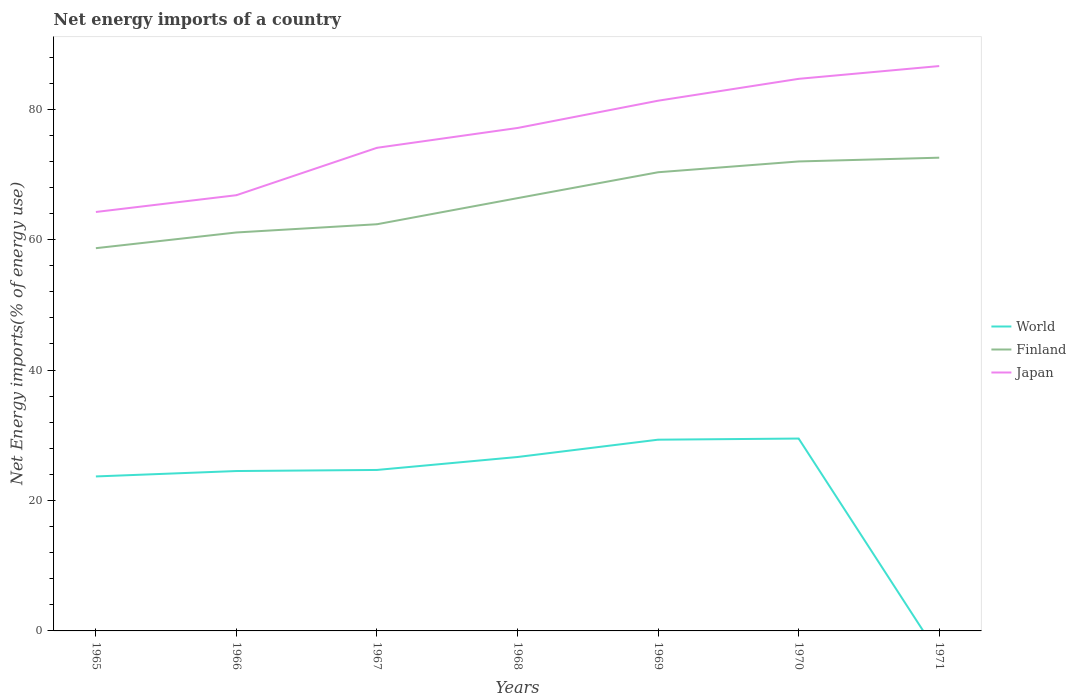How many different coloured lines are there?
Your answer should be very brief. 3. Does the line corresponding to World intersect with the line corresponding to Japan?
Keep it short and to the point. No. Across all years, what is the maximum net energy imports in Finland?
Provide a short and direct response. 58.69. What is the total net energy imports in World in the graph?
Offer a terse response. -4.81. What is the difference between the highest and the second highest net energy imports in Finland?
Your answer should be compact. 13.88. How many lines are there?
Give a very brief answer. 3. How many years are there in the graph?
Provide a short and direct response. 7. Are the values on the major ticks of Y-axis written in scientific E-notation?
Offer a terse response. No. Does the graph contain any zero values?
Make the answer very short. Yes. Where does the legend appear in the graph?
Provide a succinct answer. Center right. How are the legend labels stacked?
Your response must be concise. Vertical. What is the title of the graph?
Offer a very short reply. Net energy imports of a country. Does "Malawi" appear as one of the legend labels in the graph?
Provide a succinct answer. No. What is the label or title of the X-axis?
Offer a terse response. Years. What is the label or title of the Y-axis?
Offer a terse response. Net Energy imports(% of energy use). What is the Net Energy imports(% of energy use) in World in 1965?
Give a very brief answer. 23.69. What is the Net Energy imports(% of energy use) in Finland in 1965?
Provide a short and direct response. 58.69. What is the Net Energy imports(% of energy use) in Japan in 1965?
Offer a terse response. 64.25. What is the Net Energy imports(% of energy use) of World in 1966?
Make the answer very short. 24.52. What is the Net Energy imports(% of energy use) in Finland in 1966?
Provide a succinct answer. 61.1. What is the Net Energy imports(% of energy use) in Japan in 1966?
Your answer should be compact. 66.82. What is the Net Energy imports(% of energy use) of World in 1967?
Your answer should be compact. 24.69. What is the Net Energy imports(% of energy use) in Finland in 1967?
Ensure brevity in your answer.  62.36. What is the Net Energy imports(% of energy use) of Japan in 1967?
Your answer should be compact. 74.09. What is the Net Energy imports(% of energy use) in World in 1968?
Provide a succinct answer. 26.67. What is the Net Energy imports(% of energy use) in Finland in 1968?
Provide a short and direct response. 66.37. What is the Net Energy imports(% of energy use) in Japan in 1968?
Make the answer very short. 77.13. What is the Net Energy imports(% of energy use) of World in 1969?
Provide a succinct answer. 29.33. What is the Net Energy imports(% of energy use) in Finland in 1969?
Your response must be concise. 70.34. What is the Net Energy imports(% of energy use) in Japan in 1969?
Your response must be concise. 81.31. What is the Net Energy imports(% of energy use) of World in 1970?
Provide a short and direct response. 29.5. What is the Net Energy imports(% of energy use) of Finland in 1970?
Your answer should be very brief. 71.99. What is the Net Energy imports(% of energy use) in Japan in 1970?
Make the answer very short. 84.66. What is the Net Energy imports(% of energy use) in Finland in 1971?
Offer a terse response. 72.57. What is the Net Energy imports(% of energy use) of Japan in 1971?
Your answer should be compact. 86.62. Across all years, what is the maximum Net Energy imports(% of energy use) in World?
Your answer should be very brief. 29.5. Across all years, what is the maximum Net Energy imports(% of energy use) in Finland?
Make the answer very short. 72.57. Across all years, what is the maximum Net Energy imports(% of energy use) of Japan?
Keep it short and to the point. 86.62. Across all years, what is the minimum Net Energy imports(% of energy use) of World?
Offer a terse response. 0. Across all years, what is the minimum Net Energy imports(% of energy use) in Finland?
Offer a terse response. 58.69. Across all years, what is the minimum Net Energy imports(% of energy use) in Japan?
Your response must be concise. 64.25. What is the total Net Energy imports(% of energy use) in World in the graph?
Keep it short and to the point. 158.39. What is the total Net Energy imports(% of energy use) in Finland in the graph?
Give a very brief answer. 463.43. What is the total Net Energy imports(% of energy use) in Japan in the graph?
Offer a very short reply. 534.88. What is the difference between the Net Energy imports(% of energy use) in World in 1965 and that in 1966?
Make the answer very short. -0.83. What is the difference between the Net Energy imports(% of energy use) in Finland in 1965 and that in 1966?
Your answer should be very brief. -2.41. What is the difference between the Net Energy imports(% of energy use) in Japan in 1965 and that in 1966?
Offer a terse response. -2.57. What is the difference between the Net Energy imports(% of energy use) of World in 1965 and that in 1967?
Provide a succinct answer. -0.99. What is the difference between the Net Energy imports(% of energy use) of Finland in 1965 and that in 1967?
Your answer should be compact. -3.67. What is the difference between the Net Energy imports(% of energy use) in Japan in 1965 and that in 1967?
Offer a very short reply. -9.84. What is the difference between the Net Energy imports(% of energy use) in World in 1965 and that in 1968?
Your response must be concise. -2.98. What is the difference between the Net Energy imports(% of energy use) in Finland in 1965 and that in 1968?
Provide a succinct answer. -7.67. What is the difference between the Net Energy imports(% of energy use) in Japan in 1965 and that in 1968?
Keep it short and to the point. -12.88. What is the difference between the Net Energy imports(% of energy use) of World in 1965 and that in 1969?
Provide a succinct answer. -5.64. What is the difference between the Net Energy imports(% of energy use) of Finland in 1965 and that in 1969?
Offer a very short reply. -11.65. What is the difference between the Net Energy imports(% of energy use) of Japan in 1965 and that in 1969?
Your answer should be compact. -17.06. What is the difference between the Net Energy imports(% of energy use) of World in 1965 and that in 1970?
Your response must be concise. -5.81. What is the difference between the Net Energy imports(% of energy use) of Finland in 1965 and that in 1970?
Keep it short and to the point. -13.3. What is the difference between the Net Energy imports(% of energy use) in Japan in 1965 and that in 1970?
Make the answer very short. -20.42. What is the difference between the Net Energy imports(% of energy use) of Finland in 1965 and that in 1971?
Provide a succinct answer. -13.88. What is the difference between the Net Energy imports(% of energy use) of Japan in 1965 and that in 1971?
Your answer should be compact. -22.38. What is the difference between the Net Energy imports(% of energy use) of World in 1966 and that in 1967?
Provide a short and direct response. -0.17. What is the difference between the Net Energy imports(% of energy use) of Finland in 1966 and that in 1967?
Your answer should be compact. -1.26. What is the difference between the Net Energy imports(% of energy use) of Japan in 1966 and that in 1967?
Offer a very short reply. -7.27. What is the difference between the Net Energy imports(% of energy use) in World in 1966 and that in 1968?
Keep it short and to the point. -2.15. What is the difference between the Net Energy imports(% of energy use) in Finland in 1966 and that in 1968?
Your answer should be compact. -5.26. What is the difference between the Net Energy imports(% of energy use) in Japan in 1966 and that in 1968?
Provide a succinct answer. -10.31. What is the difference between the Net Energy imports(% of energy use) in World in 1966 and that in 1969?
Provide a succinct answer. -4.81. What is the difference between the Net Energy imports(% of energy use) of Finland in 1966 and that in 1969?
Give a very brief answer. -9.23. What is the difference between the Net Energy imports(% of energy use) in Japan in 1966 and that in 1969?
Your answer should be very brief. -14.49. What is the difference between the Net Energy imports(% of energy use) in World in 1966 and that in 1970?
Provide a succinct answer. -4.98. What is the difference between the Net Energy imports(% of energy use) in Finland in 1966 and that in 1970?
Offer a very short reply. -10.89. What is the difference between the Net Energy imports(% of energy use) of Japan in 1966 and that in 1970?
Give a very brief answer. -17.84. What is the difference between the Net Energy imports(% of energy use) of Finland in 1966 and that in 1971?
Offer a very short reply. -11.47. What is the difference between the Net Energy imports(% of energy use) in Japan in 1966 and that in 1971?
Offer a very short reply. -19.8. What is the difference between the Net Energy imports(% of energy use) in World in 1967 and that in 1968?
Give a very brief answer. -1.99. What is the difference between the Net Energy imports(% of energy use) in Finland in 1967 and that in 1968?
Your response must be concise. -4. What is the difference between the Net Energy imports(% of energy use) of Japan in 1967 and that in 1968?
Give a very brief answer. -3.04. What is the difference between the Net Energy imports(% of energy use) in World in 1967 and that in 1969?
Offer a very short reply. -4.64. What is the difference between the Net Energy imports(% of energy use) in Finland in 1967 and that in 1969?
Give a very brief answer. -7.97. What is the difference between the Net Energy imports(% of energy use) in Japan in 1967 and that in 1969?
Your response must be concise. -7.22. What is the difference between the Net Energy imports(% of energy use) of World in 1967 and that in 1970?
Provide a short and direct response. -4.81. What is the difference between the Net Energy imports(% of energy use) of Finland in 1967 and that in 1970?
Make the answer very short. -9.63. What is the difference between the Net Energy imports(% of energy use) of Japan in 1967 and that in 1970?
Your answer should be compact. -10.58. What is the difference between the Net Energy imports(% of energy use) in Finland in 1967 and that in 1971?
Offer a terse response. -10.21. What is the difference between the Net Energy imports(% of energy use) in Japan in 1967 and that in 1971?
Your answer should be very brief. -12.54. What is the difference between the Net Energy imports(% of energy use) in World in 1968 and that in 1969?
Provide a succinct answer. -2.66. What is the difference between the Net Energy imports(% of energy use) of Finland in 1968 and that in 1969?
Your answer should be very brief. -3.97. What is the difference between the Net Energy imports(% of energy use) of Japan in 1968 and that in 1969?
Ensure brevity in your answer.  -4.18. What is the difference between the Net Energy imports(% of energy use) in World in 1968 and that in 1970?
Your response must be concise. -2.83. What is the difference between the Net Energy imports(% of energy use) of Finland in 1968 and that in 1970?
Provide a short and direct response. -5.63. What is the difference between the Net Energy imports(% of energy use) in Japan in 1968 and that in 1970?
Your answer should be very brief. -7.54. What is the difference between the Net Energy imports(% of energy use) of Finland in 1968 and that in 1971?
Provide a succinct answer. -6.2. What is the difference between the Net Energy imports(% of energy use) in Japan in 1968 and that in 1971?
Ensure brevity in your answer.  -9.5. What is the difference between the Net Energy imports(% of energy use) of World in 1969 and that in 1970?
Your response must be concise. -0.17. What is the difference between the Net Energy imports(% of energy use) of Finland in 1969 and that in 1970?
Your answer should be compact. -1.65. What is the difference between the Net Energy imports(% of energy use) in Japan in 1969 and that in 1970?
Make the answer very short. -3.35. What is the difference between the Net Energy imports(% of energy use) in Finland in 1969 and that in 1971?
Keep it short and to the point. -2.23. What is the difference between the Net Energy imports(% of energy use) in Japan in 1969 and that in 1971?
Offer a very short reply. -5.31. What is the difference between the Net Energy imports(% of energy use) of Finland in 1970 and that in 1971?
Make the answer very short. -0.58. What is the difference between the Net Energy imports(% of energy use) in Japan in 1970 and that in 1971?
Your answer should be compact. -1.96. What is the difference between the Net Energy imports(% of energy use) of World in 1965 and the Net Energy imports(% of energy use) of Finland in 1966?
Keep it short and to the point. -37.41. What is the difference between the Net Energy imports(% of energy use) in World in 1965 and the Net Energy imports(% of energy use) in Japan in 1966?
Provide a short and direct response. -43.13. What is the difference between the Net Energy imports(% of energy use) in Finland in 1965 and the Net Energy imports(% of energy use) in Japan in 1966?
Your answer should be very brief. -8.13. What is the difference between the Net Energy imports(% of energy use) in World in 1965 and the Net Energy imports(% of energy use) in Finland in 1967?
Ensure brevity in your answer.  -38.67. What is the difference between the Net Energy imports(% of energy use) of World in 1965 and the Net Energy imports(% of energy use) of Japan in 1967?
Your answer should be very brief. -50.4. What is the difference between the Net Energy imports(% of energy use) in Finland in 1965 and the Net Energy imports(% of energy use) in Japan in 1967?
Make the answer very short. -15.39. What is the difference between the Net Energy imports(% of energy use) in World in 1965 and the Net Energy imports(% of energy use) in Finland in 1968?
Keep it short and to the point. -42.68. What is the difference between the Net Energy imports(% of energy use) of World in 1965 and the Net Energy imports(% of energy use) of Japan in 1968?
Your response must be concise. -53.44. What is the difference between the Net Energy imports(% of energy use) in Finland in 1965 and the Net Energy imports(% of energy use) in Japan in 1968?
Your answer should be very brief. -18.43. What is the difference between the Net Energy imports(% of energy use) in World in 1965 and the Net Energy imports(% of energy use) in Finland in 1969?
Your answer should be very brief. -46.65. What is the difference between the Net Energy imports(% of energy use) of World in 1965 and the Net Energy imports(% of energy use) of Japan in 1969?
Make the answer very short. -57.62. What is the difference between the Net Energy imports(% of energy use) in Finland in 1965 and the Net Energy imports(% of energy use) in Japan in 1969?
Make the answer very short. -22.62. What is the difference between the Net Energy imports(% of energy use) of World in 1965 and the Net Energy imports(% of energy use) of Finland in 1970?
Provide a succinct answer. -48.3. What is the difference between the Net Energy imports(% of energy use) of World in 1965 and the Net Energy imports(% of energy use) of Japan in 1970?
Offer a very short reply. -60.97. What is the difference between the Net Energy imports(% of energy use) of Finland in 1965 and the Net Energy imports(% of energy use) of Japan in 1970?
Ensure brevity in your answer.  -25.97. What is the difference between the Net Energy imports(% of energy use) of World in 1965 and the Net Energy imports(% of energy use) of Finland in 1971?
Provide a succinct answer. -48.88. What is the difference between the Net Energy imports(% of energy use) in World in 1965 and the Net Energy imports(% of energy use) in Japan in 1971?
Provide a succinct answer. -62.93. What is the difference between the Net Energy imports(% of energy use) of Finland in 1965 and the Net Energy imports(% of energy use) of Japan in 1971?
Offer a terse response. -27.93. What is the difference between the Net Energy imports(% of energy use) in World in 1966 and the Net Energy imports(% of energy use) in Finland in 1967?
Offer a terse response. -37.85. What is the difference between the Net Energy imports(% of energy use) in World in 1966 and the Net Energy imports(% of energy use) in Japan in 1967?
Provide a short and direct response. -49.57. What is the difference between the Net Energy imports(% of energy use) of Finland in 1966 and the Net Energy imports(% of energy use) of Japan in 1967?
Make the answer very short. -12.98. What is the difference between the Net Energy imports(% of energy use) in World in 1966 and the Net Energy imports(% of energy use) in Finland in 1968?
Give a very brief answer. -41.85. What is the difference between the Net Energy imports(% of energy use) of World in 1966 and the Net Energy imports(% of energy use) of Japan in 1968?
Provide a succinct answer. -52.61. What is the difference between the Net Energy imports(% of energy use) of Finland in 1966 and the Net Energy imports(% of energy use) of Japan in 1968?
Ensure brevity in your answer.  -16.02. What is the difference between the Net Energy imports(% of energy use) in World in 1966 and the Net Energy imports(% of energy use) in Finland in 1969?
Your answer should be compact. -45.82. What is the difference between the Net Energy imports(% of energy use) in World in 1966 and the Net Energy imports(% of energy use) in Japan in 1969?
Your response must be concise. -56.79. What is the difference between the Net Energy imports(% of energy use) of Finland in 1966 and the Net Energy imports(% of energy use) of Japan in 1969?
Give a very brief answer. -20.21. What is the difference between the Net Energy imports(% of energy use) in World in 1966 and the Net Energy imports(% of energy use) in Finland in 1970?
Offer a terse response. -47.47. What is the difference between the Net Energy imports(% of energy use) in World in 1966 and the Net Energy imports(% of energy use) in Japan in 1970?
Provide a short and direct response. -60.14. What is the difference between the Net Energy imports(% of energy use) of Finland in 1966 and the Net Energy imports(% of energy use) of Japan in 1970?
Make the answer very short. -23.56. What is the difference between the Net Energy imports(% of energy use) of World in 1966 and the Net Energy imports(% of energy use) of Finland in 1971?
Offer a terse response. -48.05. What is the difference between the Net Energy imports(% of energy use) of World in 1966 and the Net Energy imports(% of energy use) of Japan in 1971?
Offer a very short reply. -62.1. What is the difference between the Net Energy imports(% of energy use) in Finland in 1966 and the Net Energy imports(% of energy use) in Japan in 1971?
Make the answer very short. -25.52. What is the difference between the Net Energy imports(% of energy use) of World in 1967 and the Net Energy imports(% of energy use) of Finland in 1968?
Offer a terse response. -41.68. What is the difference between the Net Energy imports(% of energy use) of World in 1967 and the Net Energy imports(% of energy use) of Japan in 1968?
Keep it short and to the point. -52.44. What is the difference between the Net Energy imports(% of energy use) in Finland in 1967 and the Net Energy imports(% of energy use) in Japan in 1968?
Make the answer very short. -14.76. What is the difference between the Net Energy imports(% of energy use) of World in 1967 and the Net Energy imports(% of energy use) of Finland in 1969?
Your answer should be very brief. -45.65. What is the difference between the Net Energy imports(% of energy use) of World in 1967 and the Net Energy imports(% of energy use) of Japan in 1969?
Give a very brief answer. -56.62. What is the difference between the Net Energy imports(% of energy use) in Finland in 1967 and the Net Energy imports(% of energy use) in Japan in 1969?
Offer a terse response. -18.94. What is the difference between the Net Energy imports(% of energy use) in World in 1967 and the Net Energy imports(% of energy use) in Finland in 1970?
Your answer should be compact. -47.31. What is the difference between the Net Energy imports(% of energy use) in World in 1967 and the Net Energy imports(% of energy use) in Japan in 1970?
Your response must be concise. -59.98. What is the difference between the Net Energy imports(% of energy use) in Finland in 1967 and the Net Energy imports(% of energy use) in Japan in 1970?
Keep it short and to the point. -22.3. What is the difference between the Net Energy imports(% of energy use) of World in 1967 and the Net Energy imports(% of energy use) of Finland in 1971?
Offer a terse response. -47.89. What is the difference between the Net Energy imports(% of energy use) in World in 1967 and the Net Energy imports(% of energy use) in Japan in 1971?
Keep it short and to the point. -61.94. What is the difference between the Net Energy imports(% of energy use) of Finland in 1967 and the Net Energy imports(% of energy use) of Japan in 1971?
Ensure brevity in your answer.  -24.26. What is the difference between the Net Energy imports(% of energy use) in World in 1968 and the Net Energy imports(% of energy use) in Finland in 1969?
Your answer should be compact. -43.67. What is the difference between the Net Energy imports(% of energy use) of World in 1968 and the Net Energy imports(% of energy use) of Japan in 1969?
Offer a very short reply. -54.64. What is the difference between the Net Energy imports(% of energy use) in Finland in 1968 and the Net Energy imports(% of energy use) in Japan in 1969?
Keep it short and to the point. -14.94. What is the difference between the Net Energy imports(% of energy use) of World in 1968 and the Net Energy imports(% of energy use) of Finland in 1970?
Your response must be concise. -45.32. What is the difference between the Net Energy imports(% of energy use) of World in 1968 and the Net Energy imports(% of energy use) of Japan in 1970?
Your answer should be very brief. -57.99. What is the difference between the Net Energy imports(% of energy use) of Finland in 1968 and the Net Energy imports(% of energy use) of Japan in 1970?
Your response must be concise. -18.3. What is the difference between the Net Energy imports(% of energy use) in World in 1968 and the Net Energy imports(% of energy use) in Finland in 1971?
Give a very brief answer. -45.9. What is the difference between the Net Energy imports(% of energy use) in World in 1968 and the Net Energy imports(% of energy use) in Japan in 1971?
Your response must be concise. -59.95. What is the difference between the Net Energy imports(% of energy use) of Finland in 1968 and the Net Energy imports(% of energy use) of Japan in 1971?
Provide a succinct answer. -20.26. What is the difference between the Net Energy imports(% of energy use) of World in 1969 and the Net Energy imports(% of energy use) of Finland in 1970?
Your answer should be very brief. -42.67. What is the difference between the Net Energy imports(% of energy use) of World in 1969 and the Net Energy imports(% of energy use) of Japan in 1970?
Provide a succinct answer. -55.34. What is the difference between the Net Energy imports(% of energy use) of Finland in 1969 and the Net Energy imports(% of energy use) of Japan in 1970?
Provide a short and direct response. -14.32. What is the difference between the Net Energy imports(% of energy use) in World in 1969 and the Net Energy imports(% of energy use) in Finland in 1971?
Keep it short and to the point. -43.25. What is the difference between the Net Energy imports(% of energy use) in World in 1969 and the Net Energy imports(% of energy use) in Japan in 1971?
Provide a succinct answer. -57.3. What is the difference between the Net Energy imports(% of energy use) in Finland in 1969 and the Net Energy imports(% of energy use) in Japan in 1971?
Your answer should be compact. -16.28. What is the difference between the Net Energy imports(% of energy use) in World in 1970 and the Net Energy imports(% of energy use) in Finland in 1971?
Give a very brief answer. -43.07. What is the difference between the Net Energy imports(% of energy use) of World in 1970 and the Net Energy imports(% of energy use) of Japan in 1971?
Your answer should be compact. -57.12. What is the difference between the Net Energy imports(% of energy use) in Finland in 1970 and the Net Energy imports(% of energy use) in Japan in 1971?
Make the answer very short. -14.63. What is the average Net Energy imports(% of energy use) of World per year?
Your response must be concise. 22.63. What is the average Net Energy imports(% of energy use) in Finland per year?
Keep it short and to the point. 66.2. What is the average Net Energy imports(% of energy use) of Japan per year?
Ensure brevity in your answer.  76.41. In the year 1965, what is the difference between the Net Energy imports(% of energy use) of World and Net Energy imports(% of energy use) of Finland?
Make the answer very short. -35. In the year 1965, what is the difference between the Net Energy imports(% of energy use) of World and Net Energy imports(% of energy use) of Japan?
Provide a succinct answer. -40.55. In the year 1965, what is the difference between the Net Energy imports(% of energy use) of Finland and Net Energy imports(% of energy use) of Japan?
Keep it short and to the point. -5.55. In the year 1966, what is the difference between the Net Energy imports(% of energy use) of World and Net Energy imports(% of energy use) of Finland?
Provide a short and direct response. -36.58. In the year 1966, what is the difference between the Net Energy imports(% of energy use) in World and Net Energy imports(% of energy use) in Japan?
Offer a very short reply. -42.3. In the year 1966, what is the difference between the Net Energy imports(% of energy use) of Finland and Net Energy imports(% of energy use) of Japan?
Your response must be concise. -5.71. In the year 1967, what is the difference between the Net Energy imports(% of energy use) of World and Net Energy imports(% of energy use) of Finland?
Keep it short and to the point. -37.68. In the year 1967, what is the difference between the Net Energy imports(% of energy use) of World and Net Energy imports(% of energy use) of Japan?
Your answer should be compact. -49.4. In the year 1967, what is the difference between the Net Energy imports(% of energy use) in Finland and Net Energy imports(% of energy use) in Japan?
Ensure brevity in your answer.  -11.72. In the year 1968, what is the difference between the Net Energy imports(% of energy use) of World and Net Energy imports(% of energy use) of Finland?
Your response must be concise. -39.7. In the year 1968, what is the difference between the Net Energy imports(% of energy use) of World and Net Energy imports(% of energy use) of Japan?
Offer a very short reply. -50.46. In the year 1968, what is the difference between the Net Energy imports(% of energy use) in Finland and Net Energy imports(% of energy use) in Japan?
Keep it short and to the point. -10.76. In the year 1969, what is the difference between the Net Energy imports(% of energy use) of World and Net Energy imports(% of energy use) of Finland?
Your answer should be very brief. -41.01. In the year 1969, what is the difference between the Net Energy imports(% of energy use) in World and Net Energy imports(% of energy use) in Japan?
Keep it short and to the point. -51.98. In the year 1969, what is the difference between the Net Energy imports(% of energy use) of Finland and Net Energy imports(% of energy use) of Japan?
Your answer should be compact. -10.97. In the year 1970, what is the difference between the Net Energy imports(% of energy use) in World and Net Energy imports(% of energy use) in Finland?
Offer a terse response. -42.49. In the year 1970, what is the difference between the Net Energy imports(% of energy use) in World and Net Energy imports(% of energy use) in Japan?
Your response must be concise. -55.16. In the year 1970, what is the difference between the Net Energy imports(% of energy use) of Finland and Net Energy imports(% of energy use) of Japan?
Keep it short and to the point. -12.67. In the year 1971, what is the difference between the Net Energy imports(% of energy use) in Finland and Net Energy imports(% of energy use) in Japan?
Offer a very short reply. -14.05. What is the ratio of the Net Energy imports(% of energy use) in World in 1965 to that in 1966?
Your answer should be very brief. 0.97. What is the ratio of the Net Energy imports(% of energy use) of Finland in 1965 to that in 1966?
Offer a very short reply. 0.96. What is the ratio of the Net Energy imports(% of energy use) in Japan in 1965 to that in 1966?
Keep it short and to the point. 0.96. What is the ratio of the Net Energy imports(% of energy use) in World in 1965 to that in 1967?
Offer a very short reply. 0.96. What is the ratio of the Net Energy imports(% of energy use) of Finland in 1965 to that in 1967?
Offer a very short reply. 0.94. What is the ratio of the Net Energy imports(% of energy use) in Japan in 1965 to that in 1967?
Make the answer very short. 0.87. What is the ratio of the Net Energy imports(% of energy use) of World in 1965 to that in 1968?
Your response must be concise. 0.89. What is the ratio of the Net Energy imports(% of energy use) of Finland in 1965 to that in 1968?
Keep it short and to the point. 0.88. What is the ratio of the Net Energy imports(% of energy use) of Japan in 1965 to that in 1968?
Offer a very short reply. 0.83. What is the ratio of the Net Energy imports(% of energy use) of World in 1965 to that in 1969?
Offer a very short reply. 0.81. What is the ratio of the Net Energy imports(% of energy use) in Finland in 1965 to that in 1969?
Provide a succinct answer. 0.83. What is the ratio of the Net Energy imports(% of energy use) of Japan in 1965 to that in 1969?
Provide a succinct answer. 0.79. What is the ratio of the Net Energy imports(% of energy use) in World in 1965 to that in 1970?
Keep it short and to the point. 0.8. What is the ratio of the Net Energy imports(% of energy use) in Finland in 1965 to that in 1970?
Give a very brief answer. 0.82. What is the ratio of the Net Energy imports(% of energy use) of Japan in 1965 to that in 1970?
Offer a very short reply. 0.76. What is the ratio of the Net Energy imports(% of energy use) in Finland in 1965 to that in 1971?
Ensure brevity in your answer.  0.81. What is the ratio of the Net Energy imports(% of energy use) in Japan in 1965 to that in 1971?
Offer a very short reply. 0.74. What is the ratio of the Net Energy imports(% of energy use) in Finland in 1966 to that in 1967?
Provide a short and direct response. 0.98. What is the ratio of the Net Energy imports(% of energy use) in Japan in 1966 to that in 1967?
Your response must be concise. 0.9. What is the ratio of the Net Energy imports(% of energy use) of World in 1966 to that in 1968?
Offer a very short reply. 0.92. What is the ratio of the Net Energy imports(% of energy use) of Finland in 1966 to that in 1968?
Ensure brevity in your answer.  0.92. What is the ratio of the Net Energy imports(% of energy use) in Japan in 1966 to that in 1968?
Offer a very short reply. 0.87. What is the ratio of the Net Energy imports(% of energy use) of World in 1966 to that in 1969?
Your answer should be very brief. 0.84. What is the ratio of the Net Energy imports(% of energy use) of Finland in 1966 to that in 1969?
Keep it short and to the point. 0.87. What is the ratio of the Net Energy imports(% of energy use) in Japan in 1966 to that in 1969?
Provide a short and direct response. 0.82. What is the ratio of the Net Energy imports(% of energy use) in World in 1966 to that in 1970?
Provide a succinct answer. 0.83. What is the ratio of the Net Energy imports(% of energy use) of Finland in 1966 to that in 1970?
Keep it short and to the point. 0.85. What is the ratio of the Net Energy imports(% of energy use) of Japan in 1966 to that in 1970?
Make the answer very short. 0.79. What is the ratio of the Net Energy imports(% of energy use) in Finland in 1966 to that in 1971?
Give a very brief answer. 0.84. What is the ratio of the Net Energy imports(% of energy use) in Japan in 1966 to that in 1971?
Provide a short and direct response. 0.77. What is the ratio of the Net Energy imports(% of energy use) in World in 1967 to that in 1968?
Give a very brief answer. 0.93. What is the ratio of the Net Energy imports(% of energy use) in Finland in 1967 to that in 1968?
Your answer should be compact. 0.94. What is the ratio of the Net Energy imports(% of energy use) in Japan in 1967 to that in 1968?
Give a very brief answer. 0.96. What is the ratio of the Net Energy imports(% of energy use) in World in 1967 to that in 1969?
Offer a very short reply. 0.84. What is the ratio of the Net Energy imports(% of energy use) in Finland in 1967 to that in 1969?
Offer a very short reply. 0.89. What is the ratio of the Net Energy imports(% of energy use) of Japan in 1967 to that in 1969?
Provide a succinct answer. 0.91. What is the ratio of the Net Energy imports(% of energy use) of World in 1967 to that in 1970?
Make the answer very short. 0.84. What is the ratio of the Net Energy imports(% of energy use) of Finland in 1967 to that in 1970?
Make the answer very short. 0.87. What is the ratio of the Net Energy imports(% of energy use) in Japan in 1967 to that in 1970?
Your response must be concise. 0.88. What is the ratio of the Net Energy imports(% of energy use) of Finland in 1967 to that in 1971?
Offer a terse response. 0.86. What is the ratio of the Net Energy imports(% of energy use) in Japan in 1967 to that in 1971?
Offer a very short reply. 0.86. What is the ratio of the Net Energy imports(% of energy use) of World in 1968 to that in 1969?
Your response must be concise. 0.91. What is the ratio of the Net Energy imports(% of energy use) of Finland in 1968 to that in 1969?
Offer a terse response. 0.94. What is the ratio of the Net Energy imports(% of energy use) in Japan in 1968 to that in 1969?
Keep it short and to the point. 0.95. What is the ratio of the Net Energy imports(% of energy use) in World in 1968 to that in 1970?
Make the answer very short. 0.9. What is the ratio of the Net Energy imports(% of energy use) of Finland in 1968 to that in 1970?
Provide a succinct answer. 0.92. What is the ratio of the Net Energy imports(% of energy use) in Japan in 1968 to that in 1970?
Offer a very short reply. 0.91. What is the ratio of the Net Energy imports(% of energy use) in Finland in 1968 to that in 1971?
Keep it short and to the point. 0.91. What is the ratio of the Net Energy imports(% of energy use) in Japan in 1968 to that in 1971?
Offer a very short reply. 0.89. What is the ratio of the Net Energy imports(% of energy use) in Finland in 1969 to that in 1970?
Offer a terse response. 0.98. What is the ratio of the Net Energy imports(% of energy use) of Japan in 1969 to that in 1970?
Make the answer very short. 0.96. What is the ratio of the Net Energy imports(% of energy use) in Finland in 1969 to that in 1971?
Your answer should be compact. 0.97. What is the ratio of the Net Energy imports(% of energy use) of Japan in 1969 to that in 1971?
Provide a succinct answer. 0.94. What is the ratio of the Net Energy imports(% of energy use) in Japan in 1970 to that in 1971?
Keep it short and to the point. 0.98. What is the difference between the highest and the second highest Net Energy imports(% of energy use) in World?
Provide a succinct answer. 0.17. What is the difference between the highest and the second highest Net Energy imports(% of energy use) in Finland?
Keep it short and to the point. 0.58. What is the difference between the highest and the second highest Net Energy imports(% of energy use) in Japan?
Offer a very short reply. 1.96. What is the difference between the highest and the lowest Net Energy imports(% of energy use) of World?
Your answer should be very brief. 29.5. What is the difference between the highest and the lowest Net Energy imports(% of energy use) of Finland?
Your answer should be compact. 13.88. What is the difference between the highest and the lowest Net Energy imports(% of energy use) in Japan?
Your answer should be compact. 22.38. 